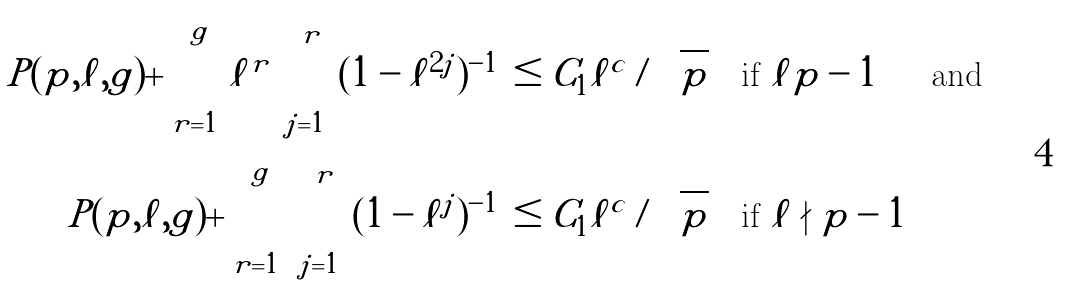Convert formula to latex. <formula><loc_0><loc_0><loc_500><loc_500>\left | P ( p , \ell , g ) + \sum _ { r = 1 } ^ { g } \ell ^ { r } \prod _ { j = 1 } ^ { r } ( 1 - \ell ^ { 2 j } ) ^ { - 1 } \right | & \leq C _ { 1 } \ell ^ { c } / \sqrt { p } \quad \text {if $\ell | p-1$ \quad \text { and}} \\ \left | P ( p , \ell , g ) + \sum _ { r = 1 } ^ { g } \prod _ { j = 1 } ^ { r } ( 1 - \ell ^ { j } ) ^ { - 1 } \right | & \leq C _ { 1 } \ell ^ { c } / \sqrt { p } \quad \text {if $\ell \nmid p-1$}</formula> 